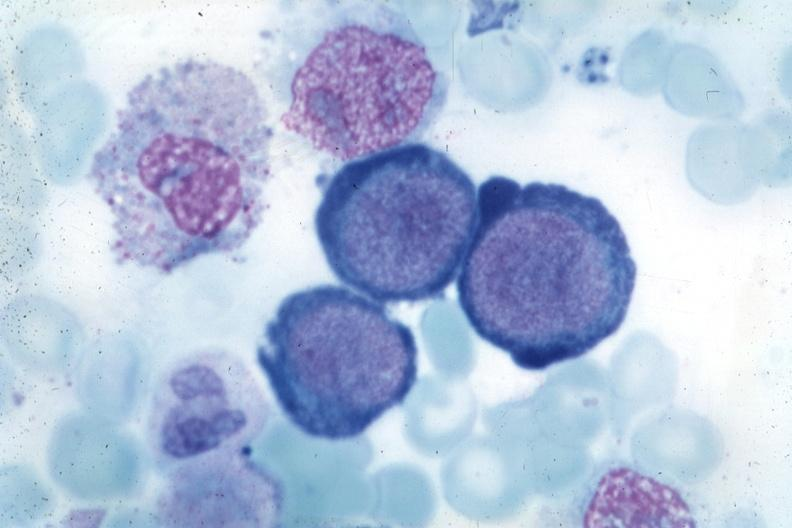what is present?
Answer the question using a single word or phrase. Bone marrow 